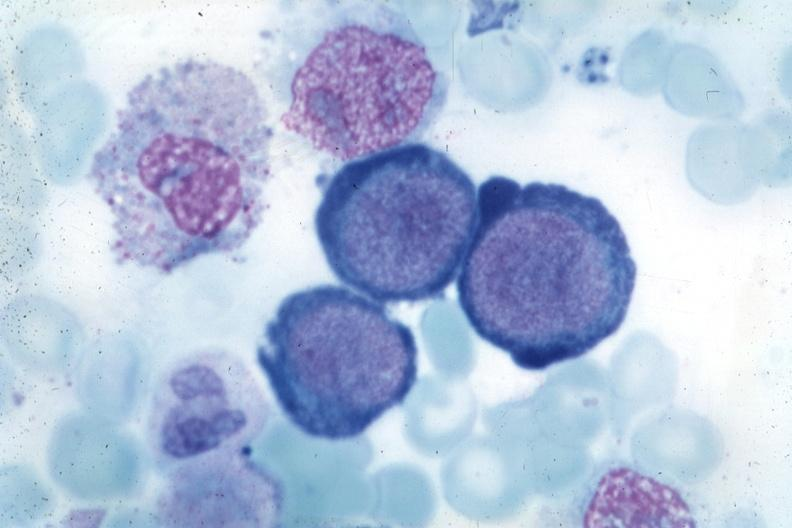what is present?
Answer the question using a single word or phrase. Bone marrow 